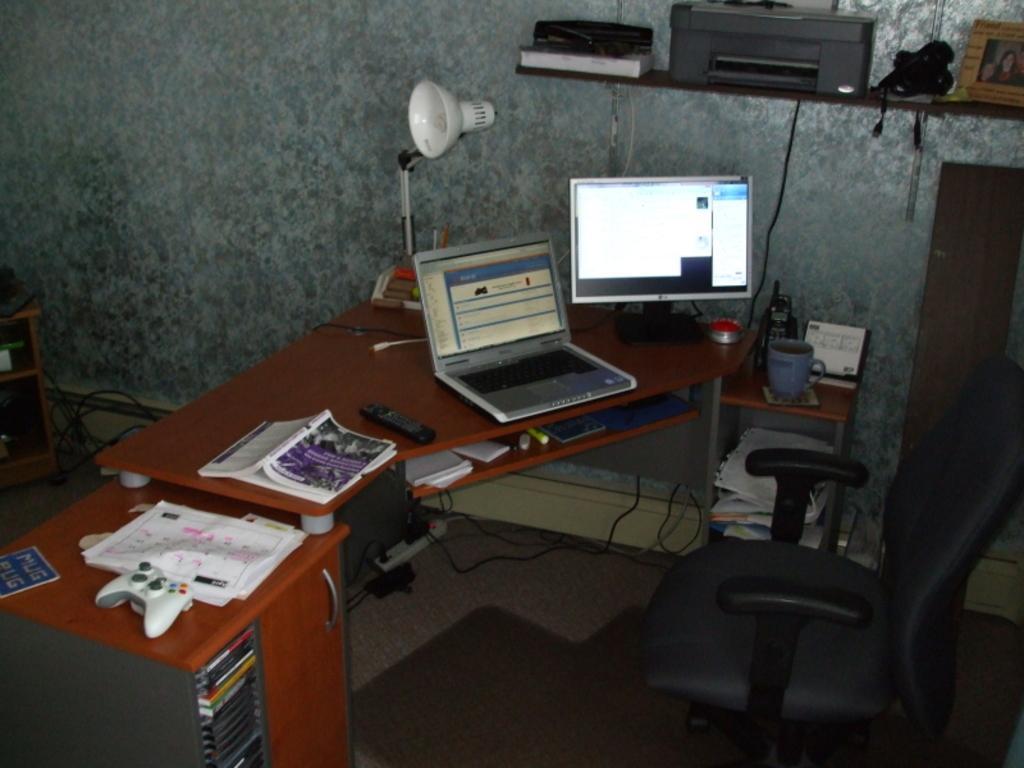Please provide a concise description of this image. In this image, we can see wooden table, cupboard, holder and video game player, books, laptop. Here there is a monitor. On right side we can see black chair, cup. Some items are placed on the table. Floor we can see. On left side, we can see cupboard, wires. Here there is a ash color wall and table lamp. On top of the table, there is a shelf. Few items are placed on the shelf. 